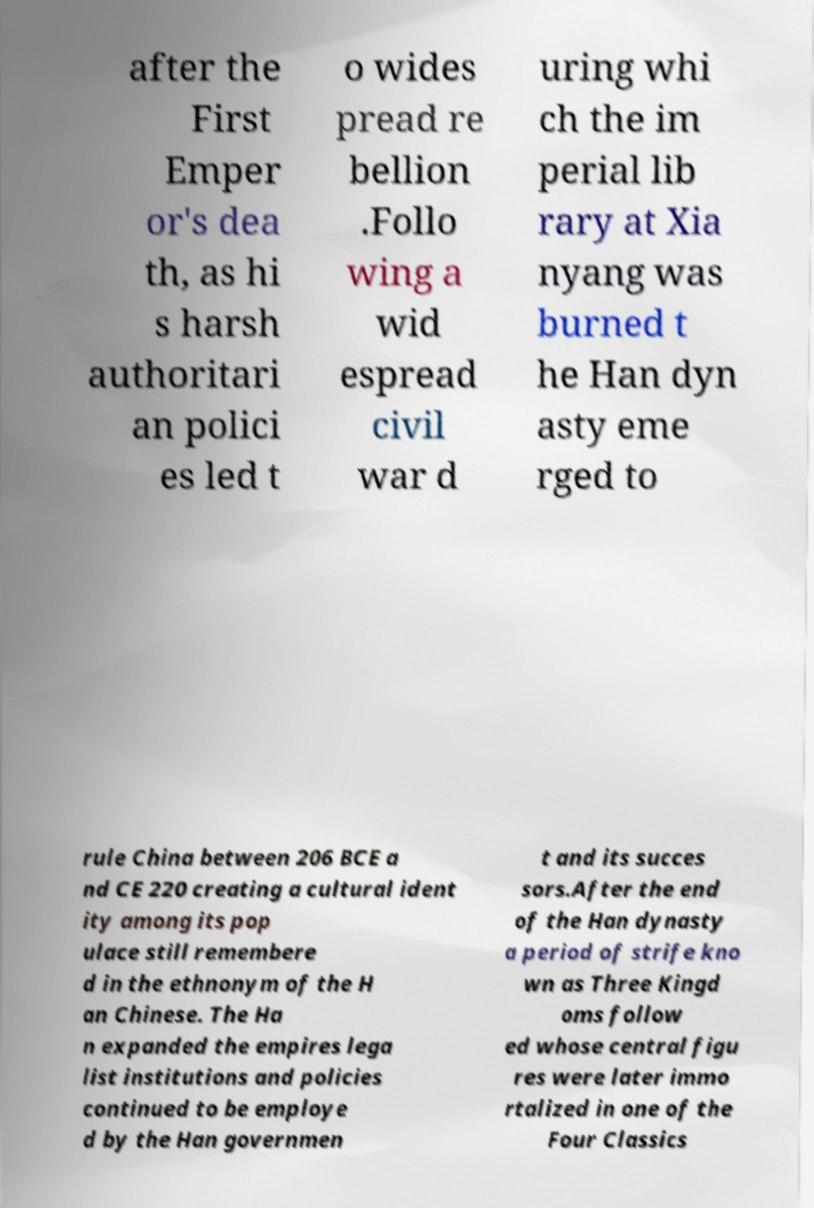Can you accurately transcribe the text from the provided image for me? after the First Emper or's dea th, as hi s harsh authoritari an polici es led t o wides pread re bellion .Follo wing a wid espread civil war d uring whi ch the im perial lib rary at Xia nyang was burned t he Han dyn asty eme rged to rule China between 206 BCE a nd CE 220 creating a cultural ident ity among its pop ulace still remembere d in the ethnonym of the H an Chinese. The Ha n expanded the empires lega list institutions and policies continued to be employe d by the Han governmen t and its succes sors.After the end of the Han dynasty a period of strife kno wn as Three Kingd oms follow ed whose central figu res were later immo rtalized in one of the Four Classics 